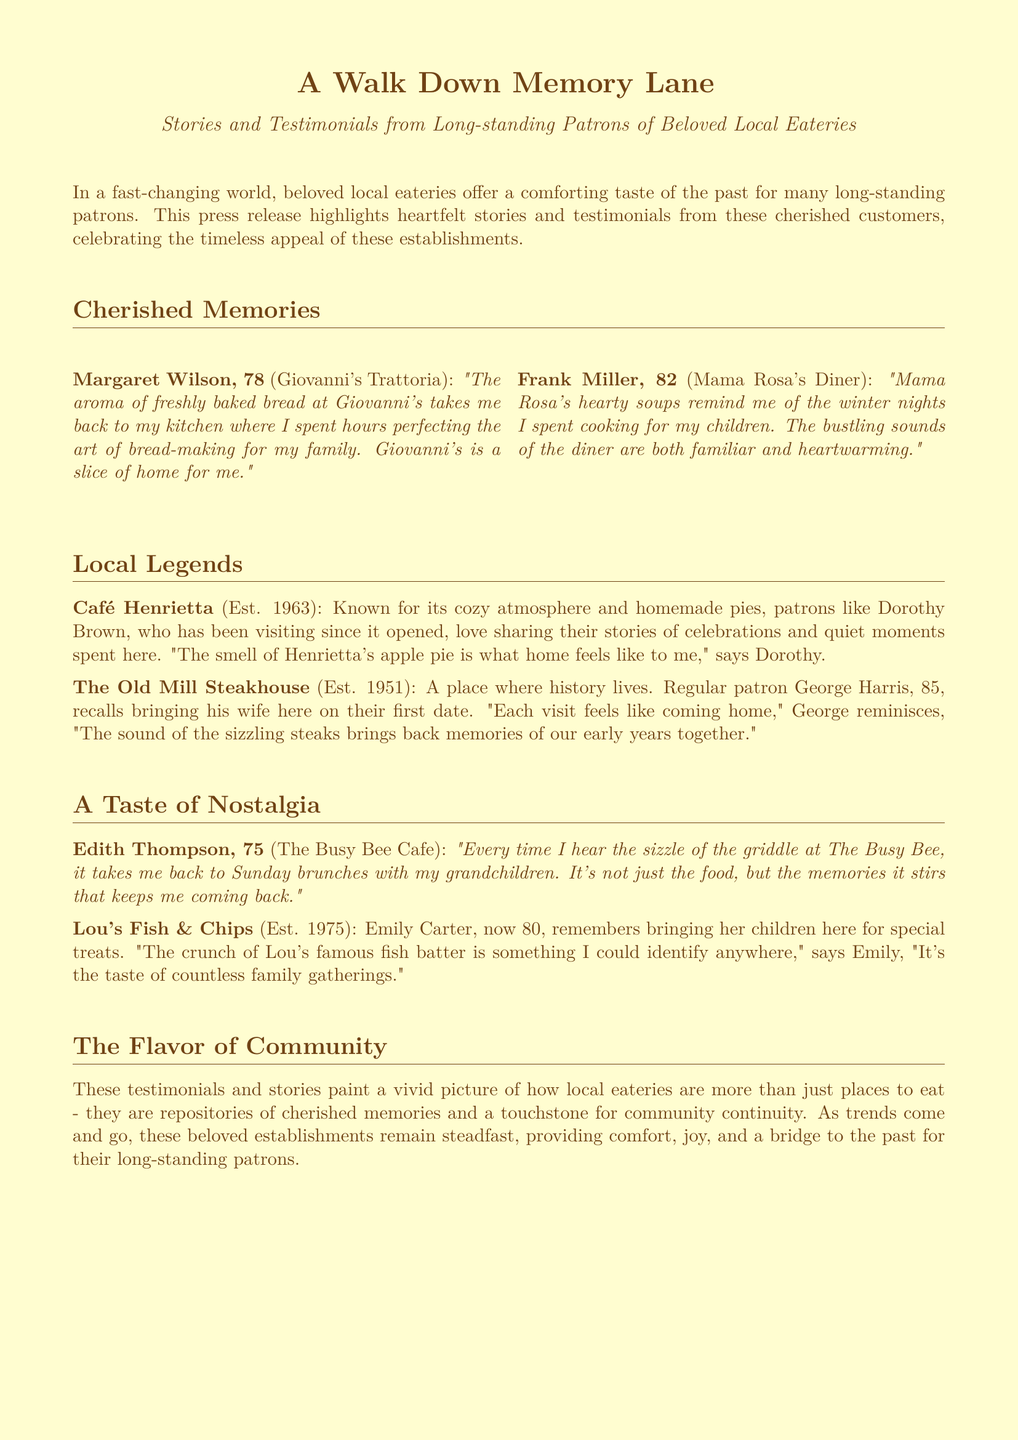what is the main theme of the press release? The main theme focuses on the nostalgic experiences of long-standing patrons of local eateries and their cherished memories.
Answer: nostalgia who is a patron of Giovanni's Trattoria? The patron mentioned is Margaret Wilson.
Answer: Margaret Wilson what smell does Dorothy Brown associate with Café Henrietta? Dorothy associates the smell of apple pie with Café Henrietta.
Answer: apple pie in what year was The Old Mill Steakhouse established? The Old Mill Steakhouse was established in 1951.
Answer: 1951 what cooking activity does Frank Miller reminisce about? Frank Miller reminisces about cooking hearty soups for his children.
Answer: cooking soups how old is Emily Carter? Emily Carter is 80 years old.
Answer: 80 what sound at The Busy Bee Cafe evokes memories for Edith Thompson? The sizzle of the griddle evokes memories for Edith Thompson.
Answer: sizzle what is a common theme in the testimonials of patrons? A common theme is the connection of food with personal memories and family gatherings.
Answer: personal memories how does the press release describe local eateries? It describes them as repositories of cherished memories and a touchstone for community continuity.
Answer: repositories of cherished memories 